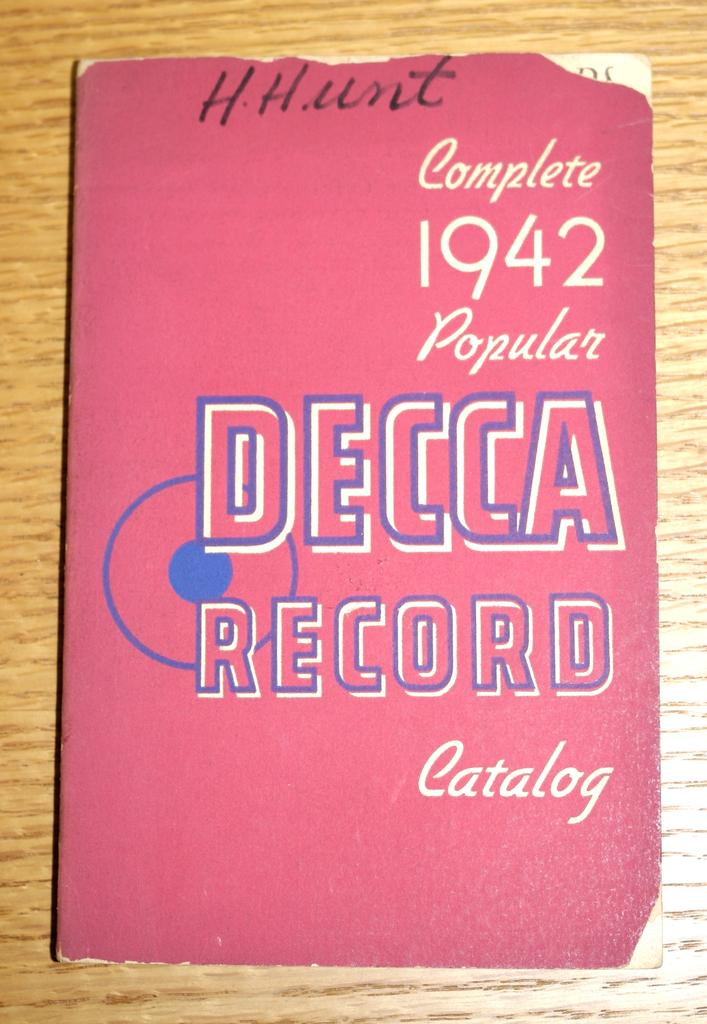Provide a one-sentence caption for the provided image. The Decca Record catalog, complete 1942 popular version. 